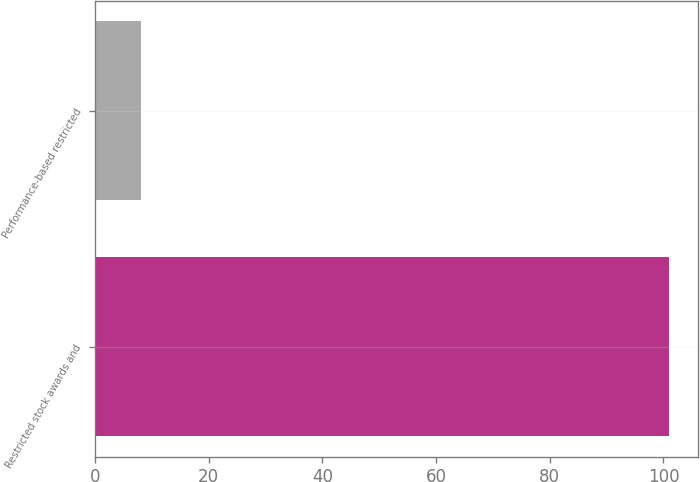Convert chart. <chart><loc_0><loc_0><loc_500><loc_500><bar_chart><fcel>Restricted stock awards and<fcel>Performance-based restricted<nl><fcel>101<fcel>8<nl></chart> 